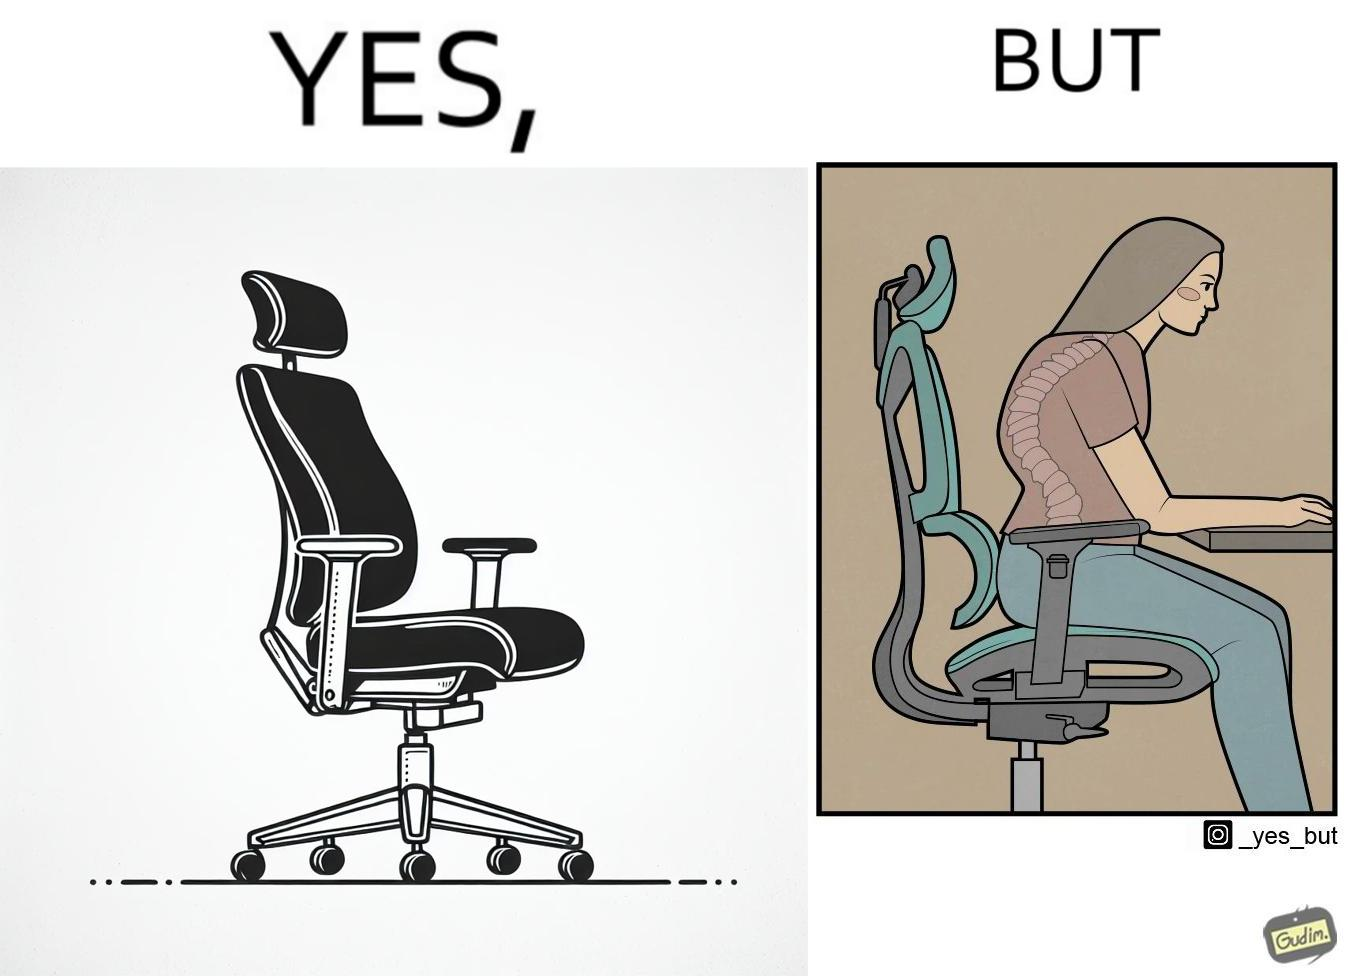Does this image contain satire or humor? Yes, this image is satirical. 